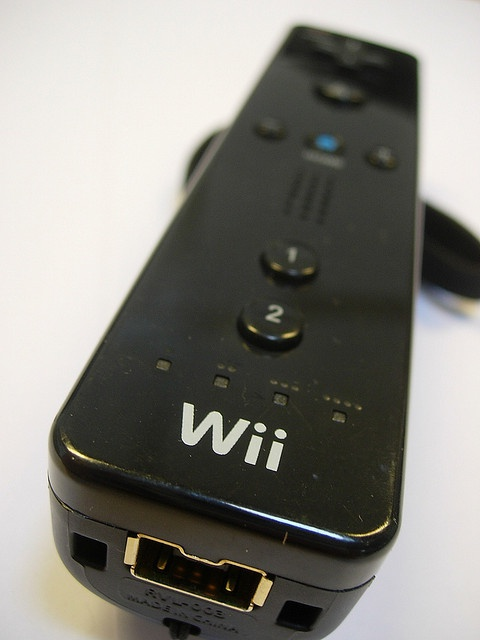Describe the objects in this image and their specific colors. I can see a remote in lightgray, black, and gray tones in this image. 